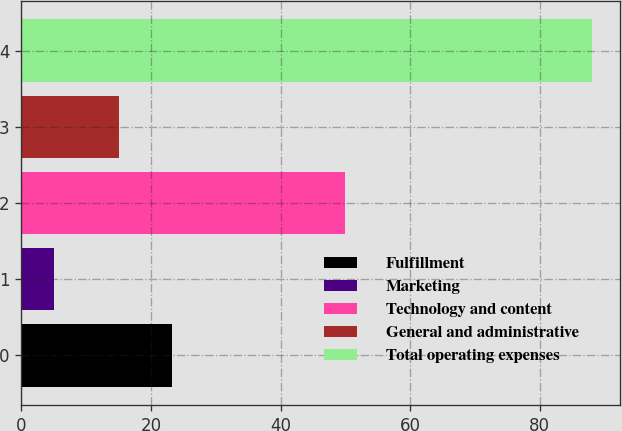Convert chart. <chart><loc_0><loc_0><loc_500><loc_500><bar_chart><fcel>Fulfillment<fcel>Marketing<fcel>Technology and content<fcel>General and administrative<fcel>Total operating expenses<nl><fcel>23.3<fcel>5<fcel>50<fcel>15<fcel>88<nl></chart> 